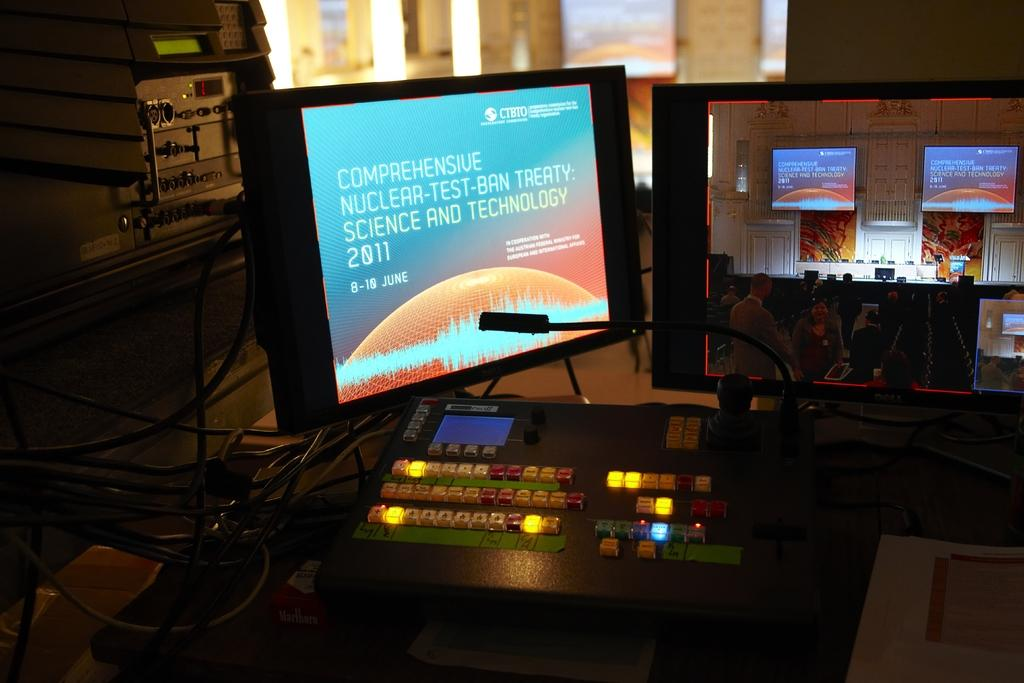<image>
Share a concise interpretation of the image provided. A computer station for displaying the Science and Technology information to the screens on stage at a conference. 